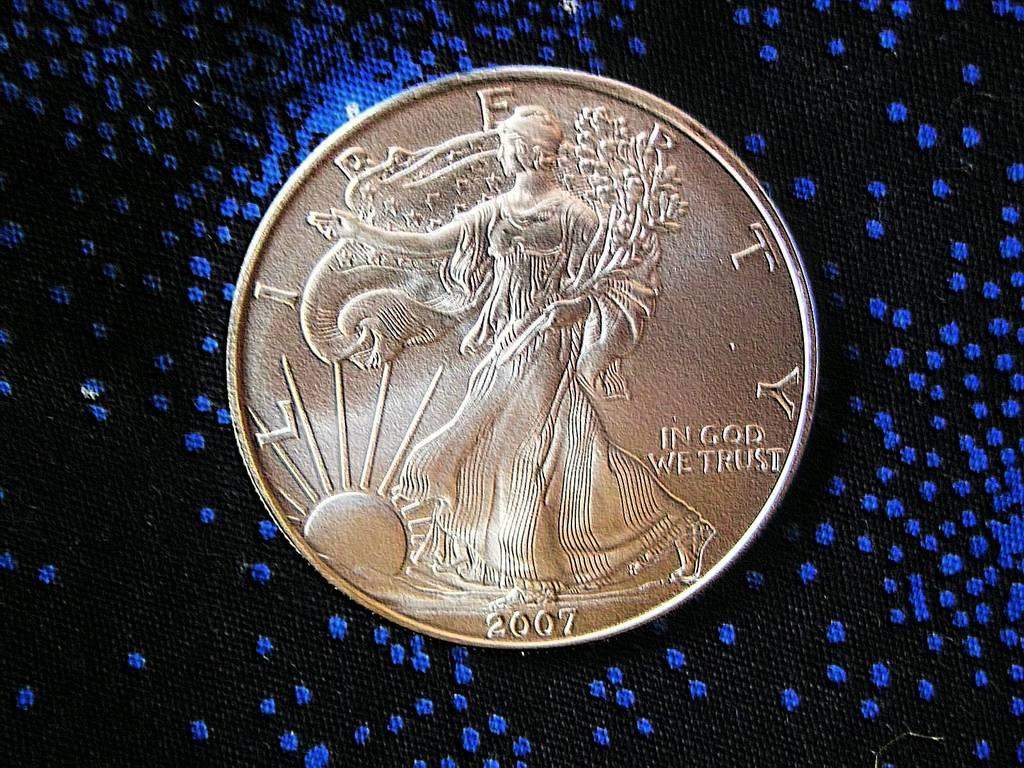<image>
Describe the image concisely. A golden coin from 2007 says "in gold we trust" 